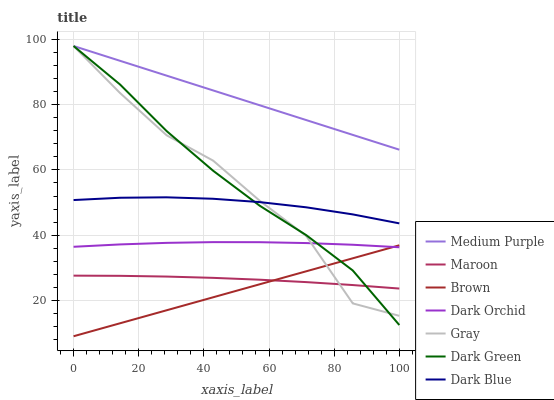Does Brown have the minimum area under the curve?
Answer yes or no. Yes. Does Medium Purple have the maximum area under the curve?
Answer yes or no. Yes. Does Gray have the minimum area under the curve?
Answer yes or no. No. Does Gray have the maximum area under the curve?
Answer yes or no. No. Is Brown the smoothest?
Answer yes or no. Yes. Is Gray the roughest?
Answer yes or no. Yes. Is Dark Orchid the smoothest?
Answer yes or no. No. Is Dark Orchid the roughest?
Answer yes or no. No. Does Brown have the lowest value?
Answer yes or no. Yes. Does Gray have the lowest value?
Answer yes or no. No. Does Dark Green have the highest value?
Answer yes or no. Yes. Does Dark Orchid have the highest value?
Answer yes or no. No. Is Dark Blue less than Medium Purple?
Answer yes or no. Yes. Is Medium Purple greater than Maroon?
Answer yes or no. Yes. Does Medium Purple intersect Gray?
Answer yes or no. Yes. Is Medium Purple less than Gray?
Answer yes or no. No. Is Medium Purple greater than Gray?
Answer yes or no. No. Does Dark Blue intersect Medium Purple?
Answer yes or no. No. 